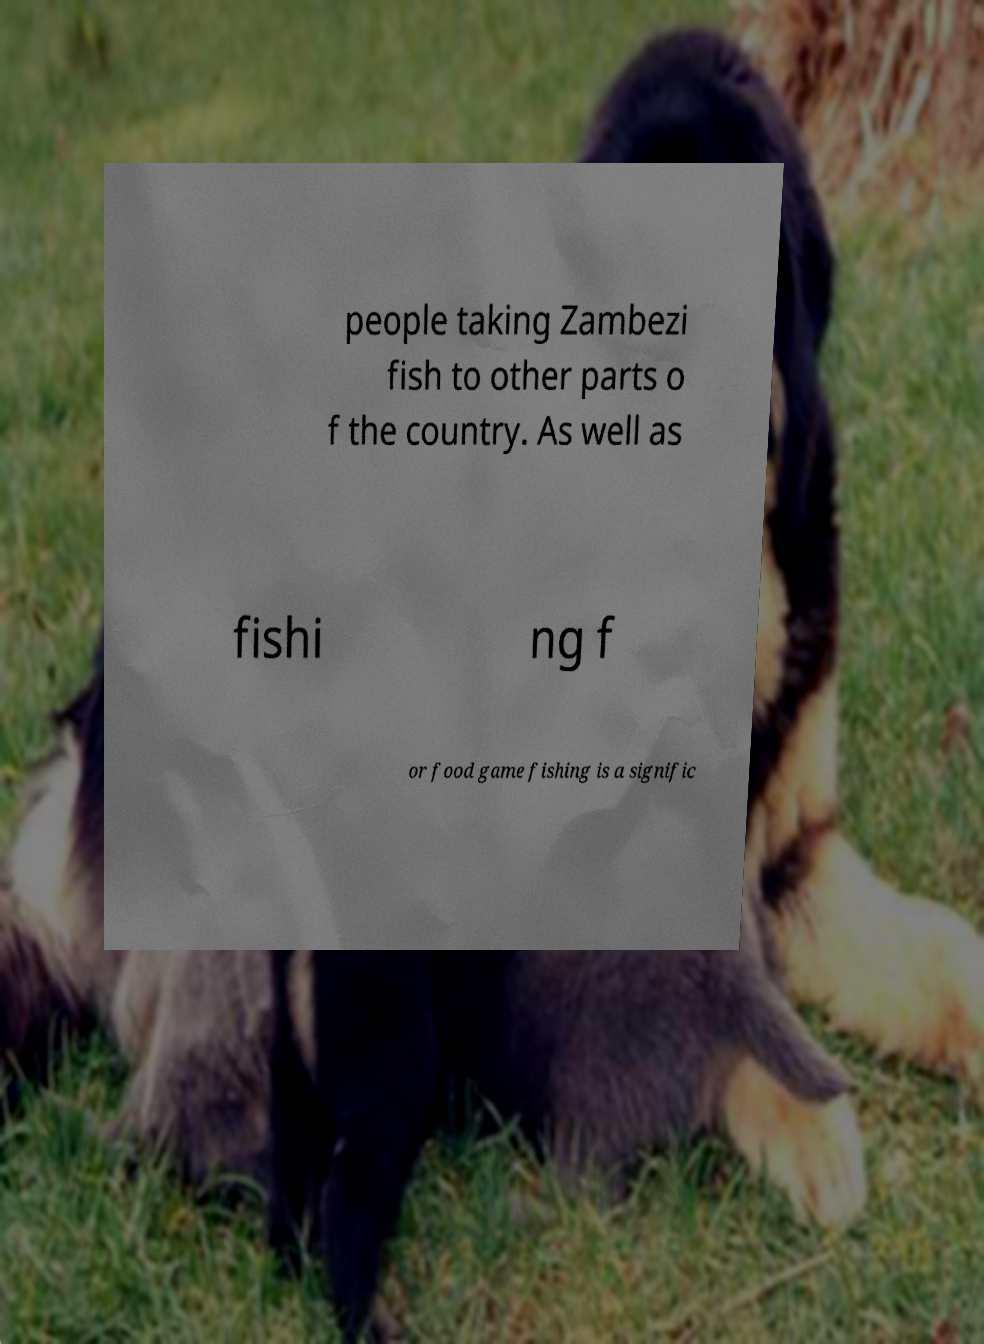What messages or text are displayed in this image? I need them in a readable, typed format. people taking Zambezi fish to other parts o f the country. As well as fishi ng f or food game fishing is a signific 